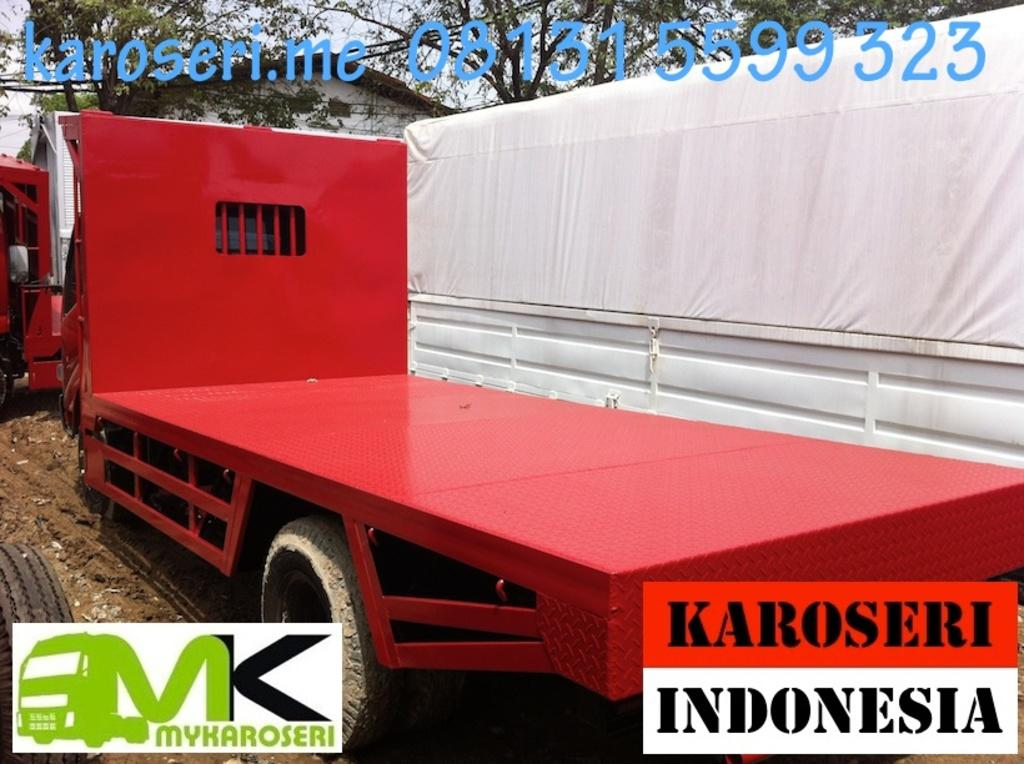What can be seen in the background of the image? There is a truck, trees, and a house in the background of the image. What type of text is present in the image? There is text at the top and bottom of the image. What type of cake is being used to power the engine of the truck in the image? There is no cake or engine present in the image; it features a truck, trees, and a house in the background. What type of writing instrument is being used to create the text in the image? There is no indication of the writing instrument used to create the text in the image. 